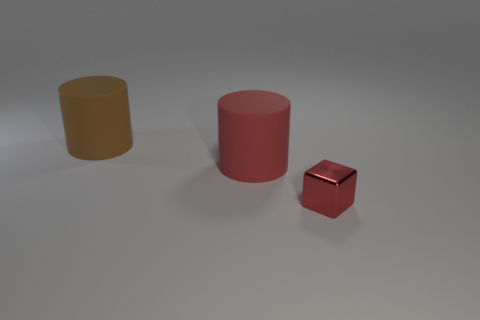Add 3 small blue rubber things. How many objects exist? 6 Subtract all cubes. How many objects are left? 2 Add 1 metallic things. How many metallic things are left? 2 Add 2 big matte objects. How many big matte objects exist? 4 Subtract 1 brown cylinders. How many objects are left? 2 Subtract all tiny red balls. Subtract all big objects. How many objects are left? 1 